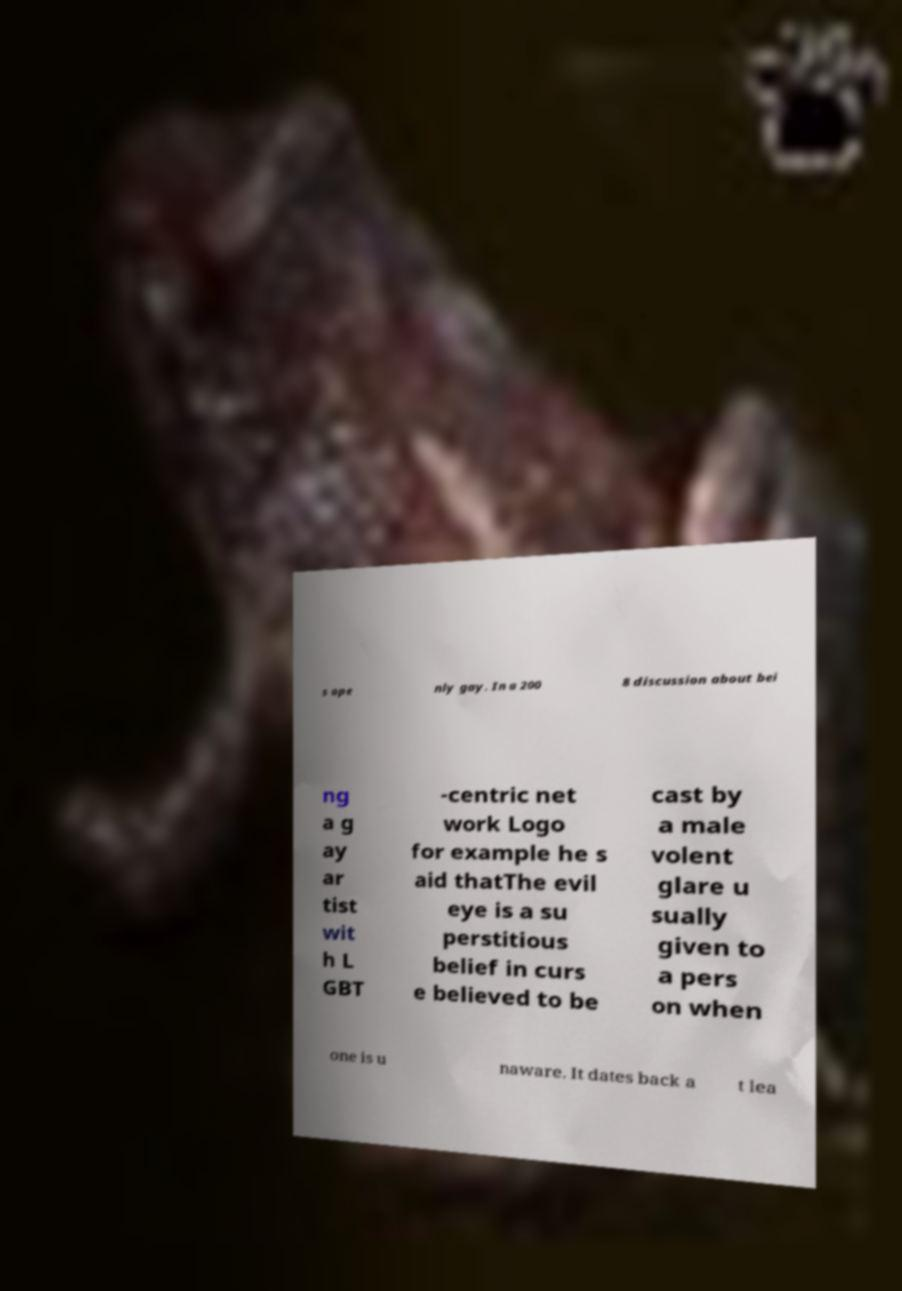There's text embedded in this image that I need extracted. Can you transcribe it verbatim? s ope nly gay. In a 200 8 discussion about bei ng a g ay ar tist wit h L GBT -centric net work Logo for example he s aid thatThe evil eye is a su perstitious belief in curs e believed to be cast by a male volent glare u sually given to a pers on when one is u naware. It dates back a t lea 